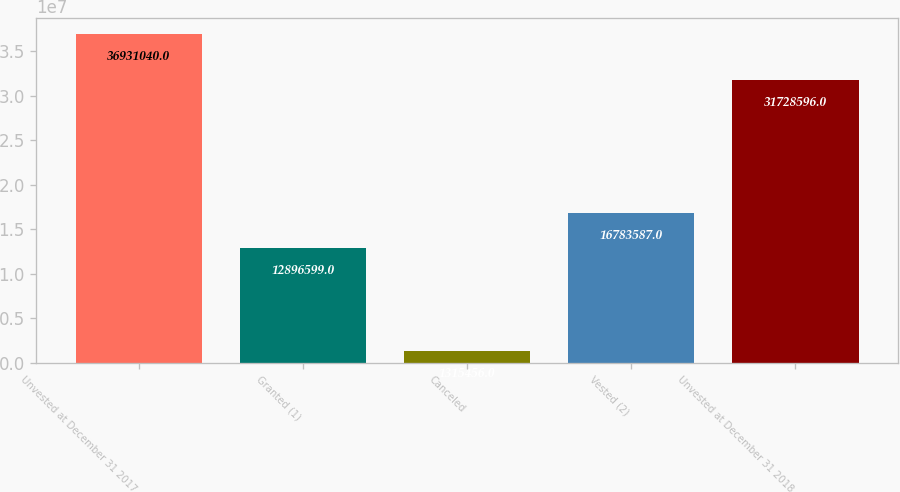Convert chart. <chart><loc_0><loc_0><loc_500><loc_500><bar_chart><fcel>Unvested at December 31 2017<fcel>Granted (1)<fcel>Canceled<fcel>Vested (2)<fcel>Unvested at December 31 2018<nl><fcel>3.6931e+07<fcel>1.28966e+07<fcel>1.31546e+06<fcel>1.67836e+07<fcel>3.17286e+07<nl></chart> 